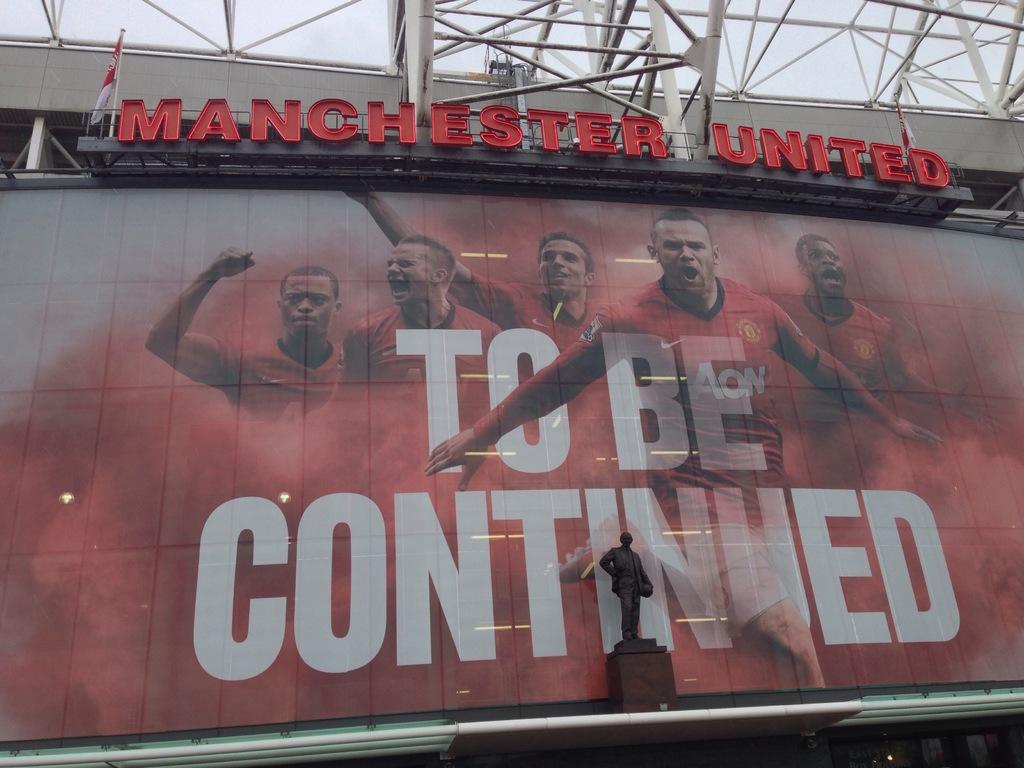What does the billboard say?
Offer a very short reply. To be continued. 